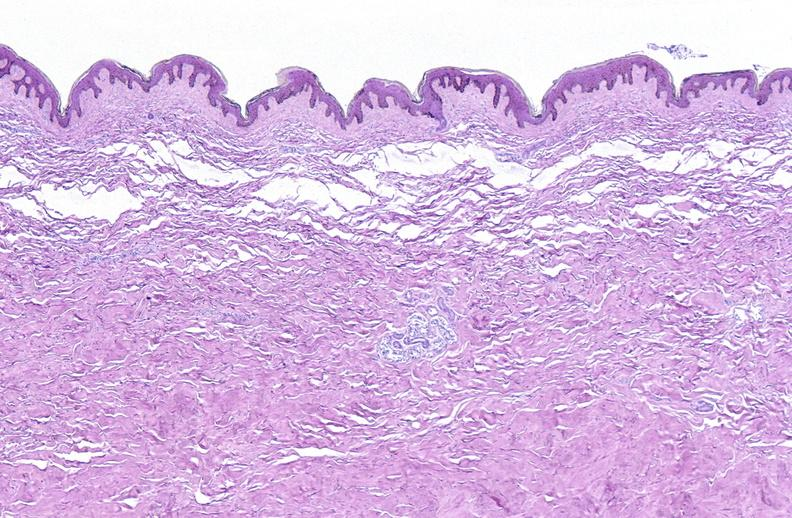does this image show scleroderma?
Answer the question using a single word or phrase. Yes 